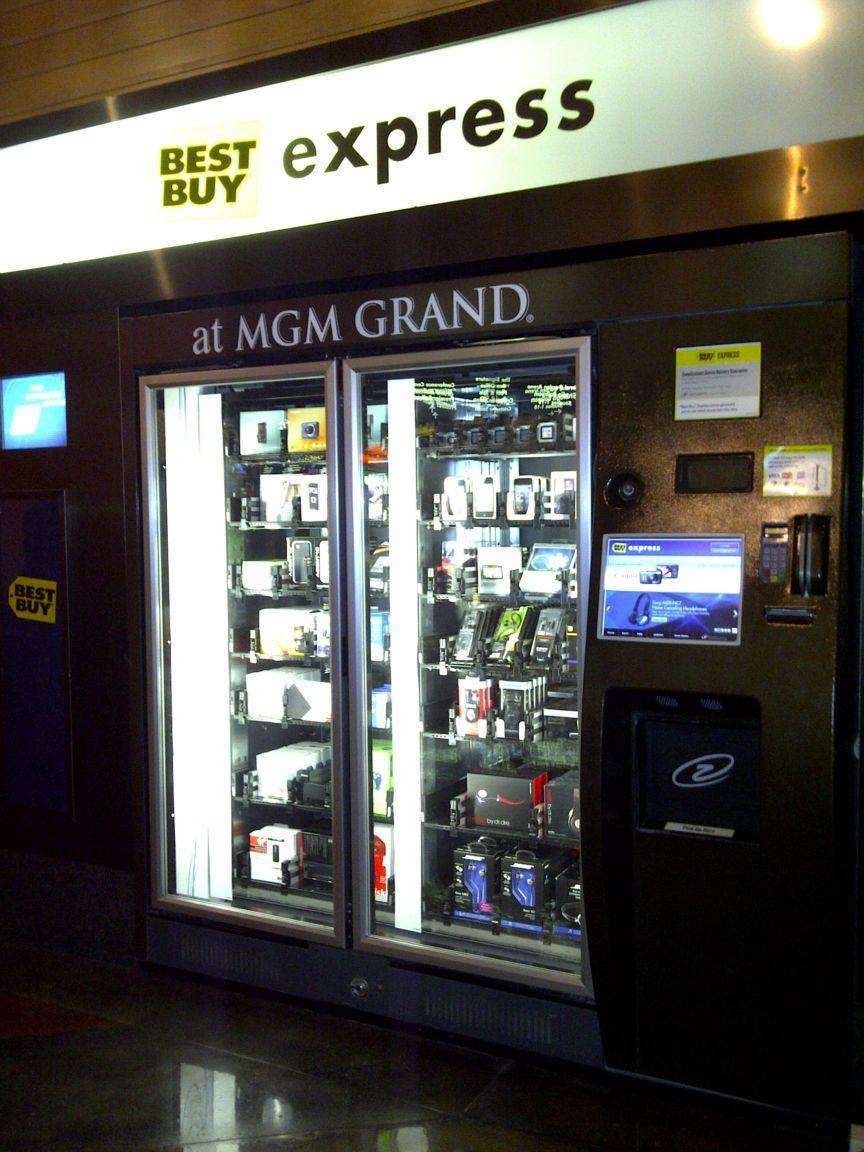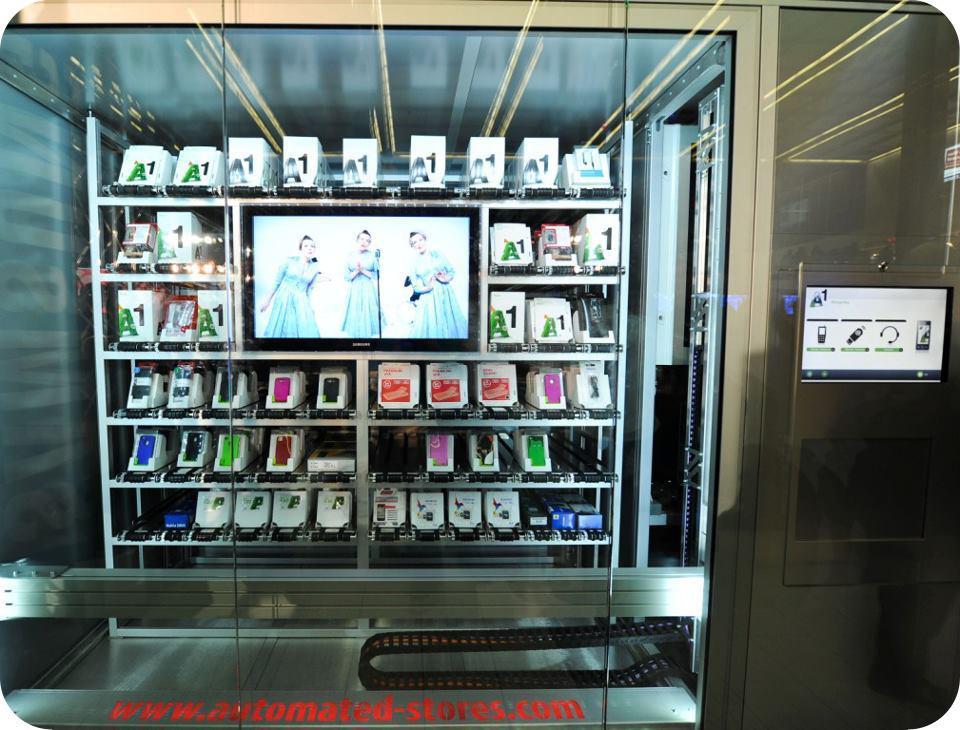The first image is the image on the left, the second image is the image on the right. Assess this claim about the two images: "One of the image contains one or more vending machines that are facing to the left.". Correct or not? Answer yes or no. Yes. The first image is the image on the left, the second image is the image on the right. For the images displayed, is the sentence "At least one image shows three or more vending machines." factually correct? Answer yes or no. No. 